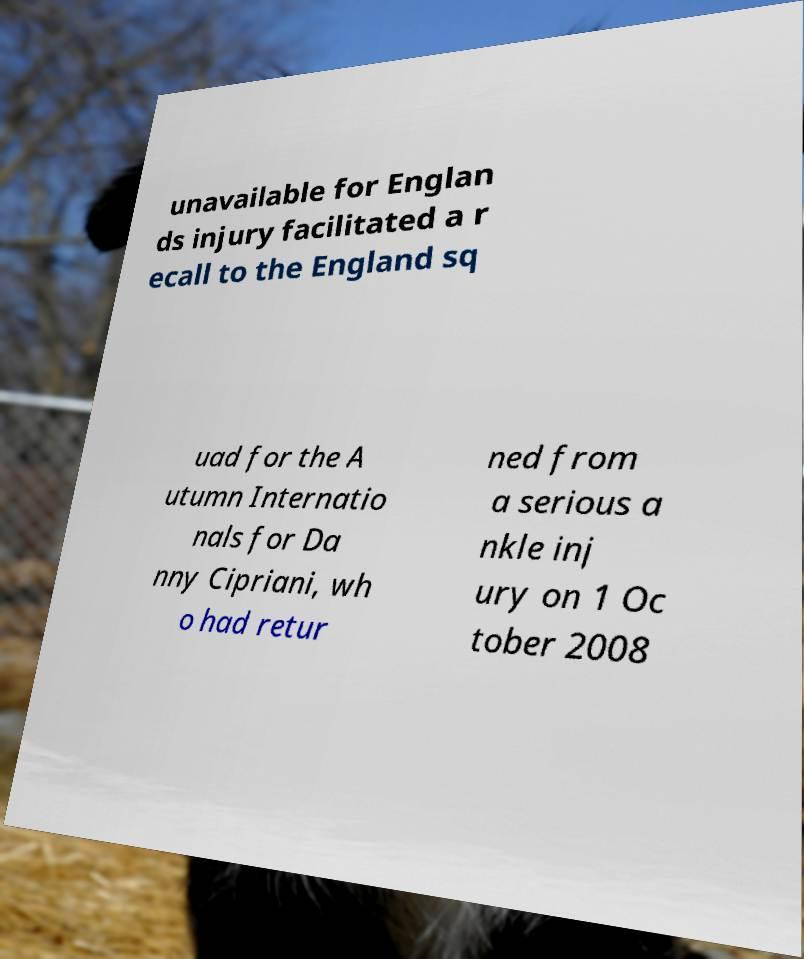What messages or text are displayed in this image? I need them in a readable, typed format. unavailable for Englan ds injury facilitated a r ecall to the England sq uad for the A utumn Internatio nals for Da nny Cipriani, wh o had retur ned from a serious a nkle inj ury on 1 Oc tober 2008 